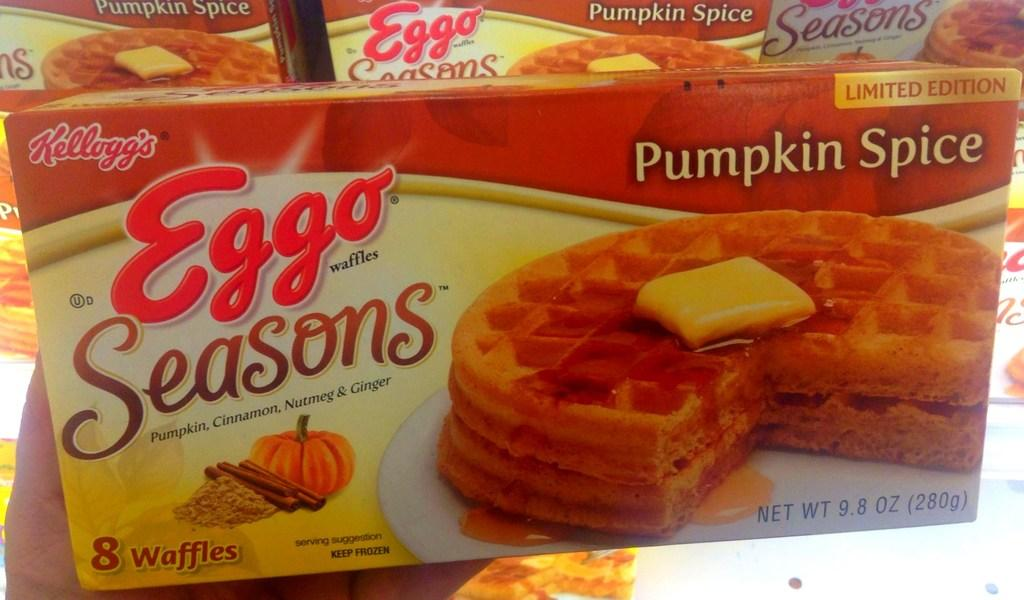What is being held by the hand in the image? The hand is holding a box. Can you describe the appearance of the box? The box is red, yellow, and white in color. What else can be seen in the background of the image? There are other boxes visible in the background of the image. What type of vacation is being planned by the eyes in the image? There are no eyes present in the image, so it is not possible to determine if a vacation is being planned. 